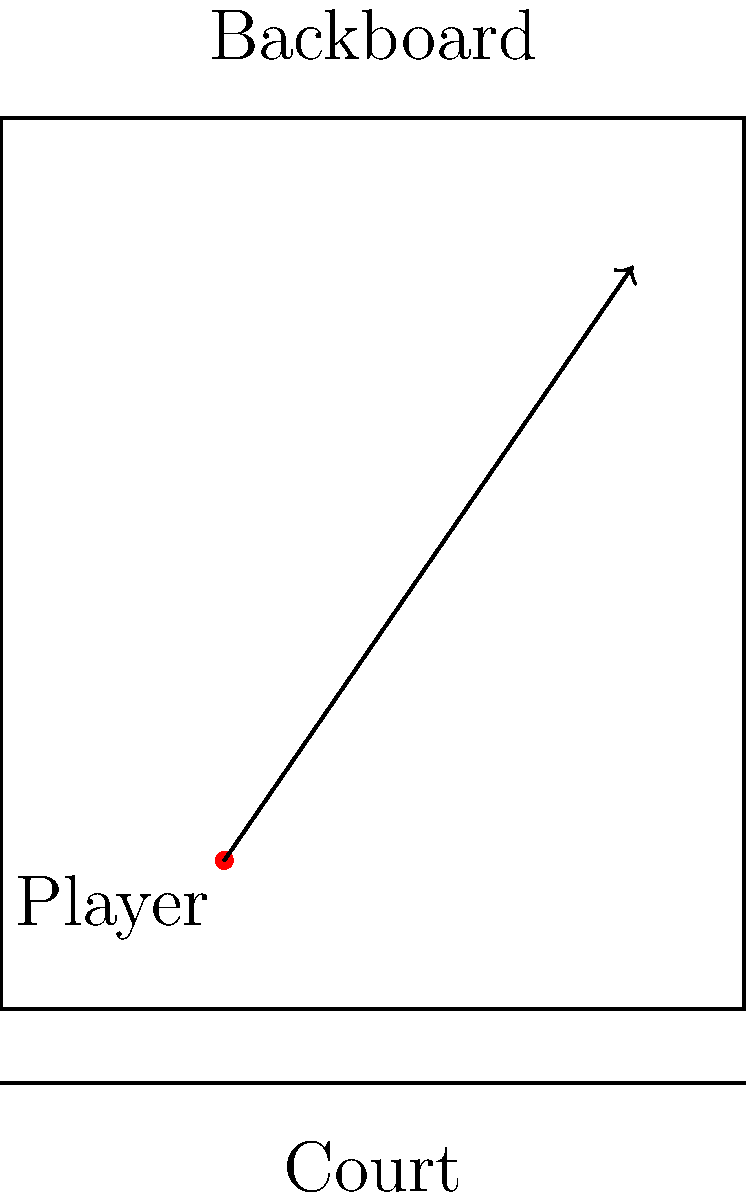As a seasoned basketball player, you're practicing bank shots. You're positioned 3 feet from the baseline and 2 feet inside the three-point line. The backboard is 10 feet wide and 12 feet high. Assuming the optimal bank shot hits the backboard at 85% of its height, what is the ideal angle $\theta$ (in degrees, rounded to the nearest whole number) for your shot relative to the horizontal plane? Let's approach this step-by-step:

1) First, let's define our coordinate system. Let the bottom left corner of the backboard be (0,0), and use feet as our unit of measurement.

2) The player's position is:
   x = 3 feet (from baseline)
   y = 2 feet (inside three-point line)

3) The target point on the backboard is:
   x = 10 feet (width of backboard)
   y = 12 * 0.85 = 10.2 feet (85% of backboard height)

4) We can calculate the differences:
   Δx = 10 - 3 = 7 feet
   Δy = 10.2 - 2 = 8.2 feet

5) The angle can be calculated using the arctangent function:

   $$\theta = \arctan(\frac{\Delta y}{\Delta x})$$

6) Plugging in our values:

   $$\theta = \arctan(\frac{8.2}{7})$$

7) Using a calculator or computer:

   $$\theta \approx 49.53 \text{ degrees}$$

8) Rounding to the nearest whole number:

   $$\theta \approx 50 \text{ degrees}$$
Answer: 50 degrees 